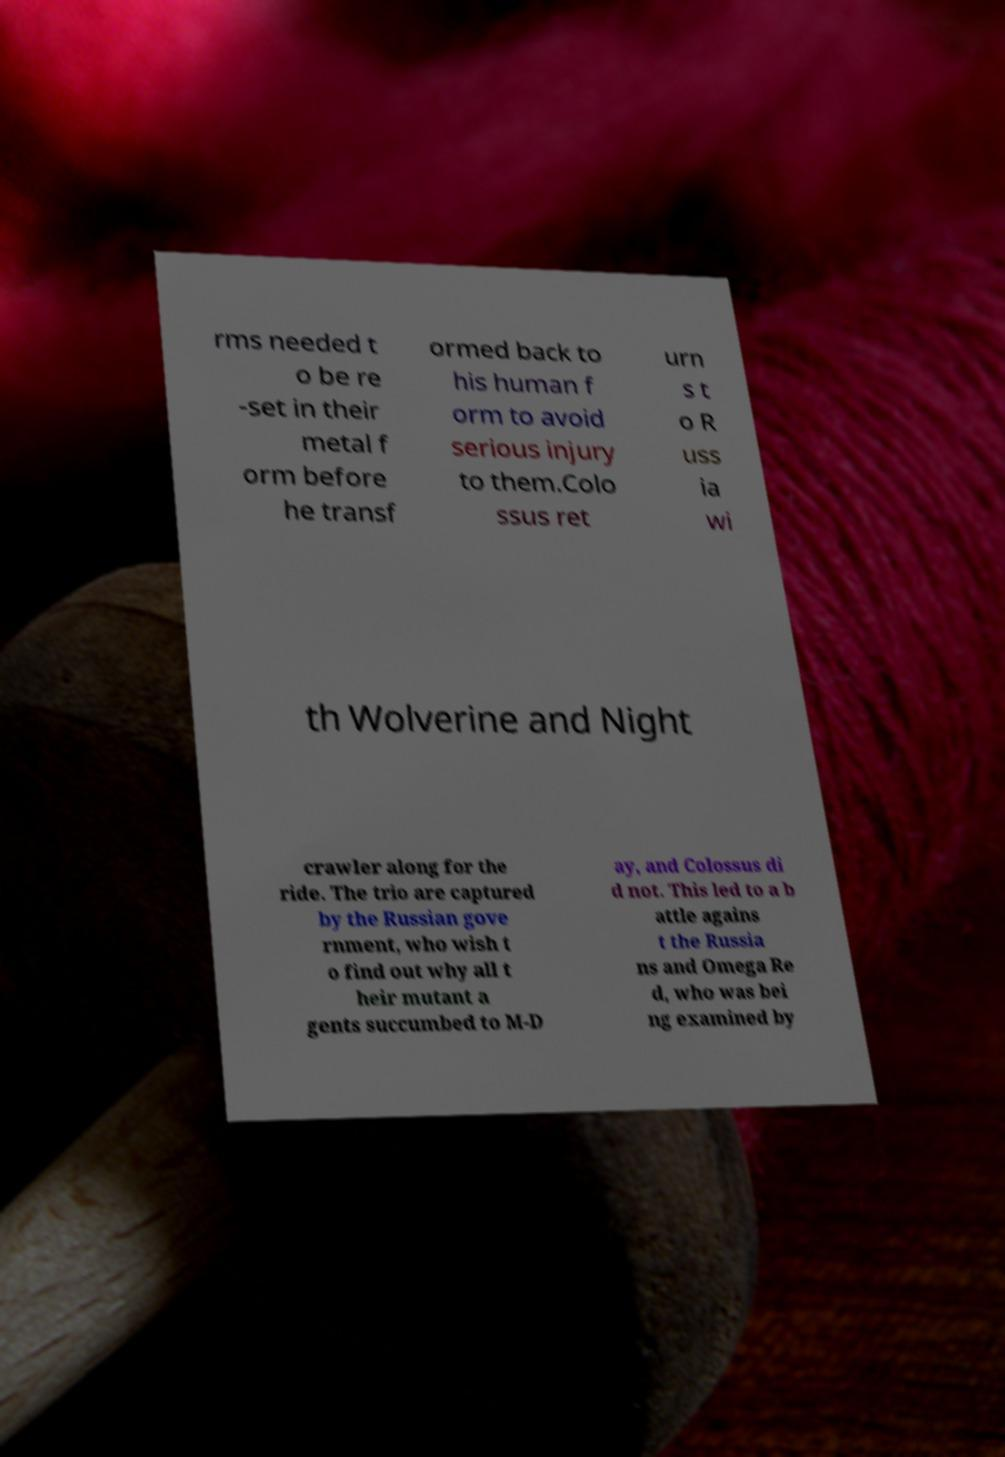Can you read and provide the text displayed in the image?This photo seems to have some interesting text. Can you extract and type it out for me? rms needed t o be re -set in their metal f orm before he transf ormed back to his human f orm to avoid serious injury to them.Colo ssus ret urn s t o R uss ia wi th Wolverine and Night crawler along for the ride. The trio are captured by the Russian gove rnment, who wish t o find out why all t heir mutant a gents succumbed to M-D ay, and Colossus di d not. This led to a b attle agains t the Russia ns and Omega Re d, who was bei ng examined by 